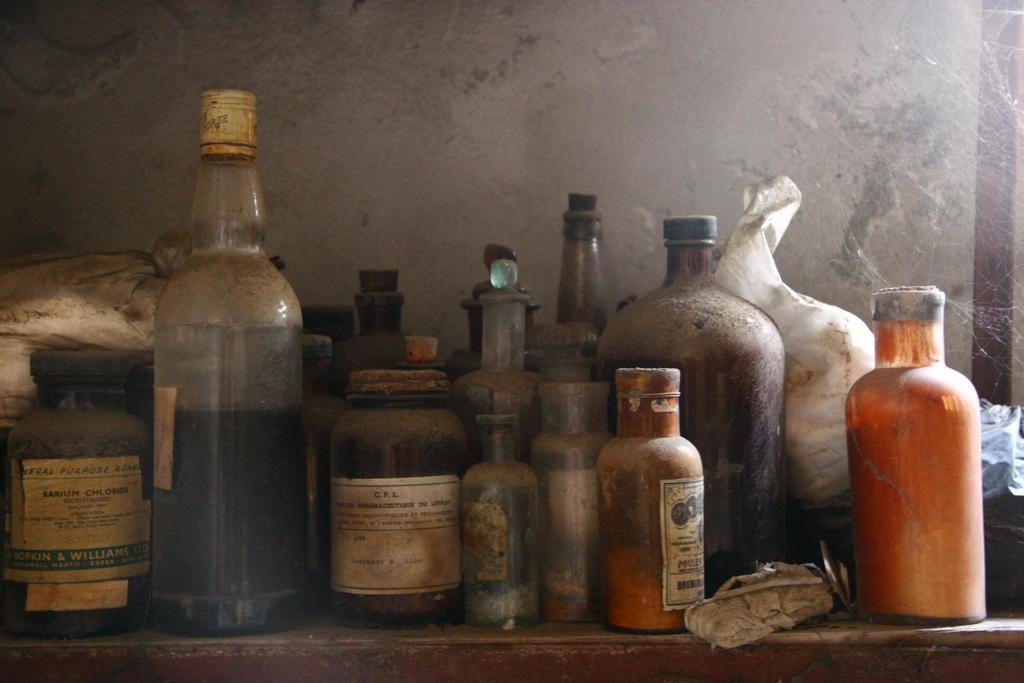Please provide a concise description of this image. There is a big table of brown color, On that table there are some bottles and some bags which are in white color and in the background there is a white color wall. 